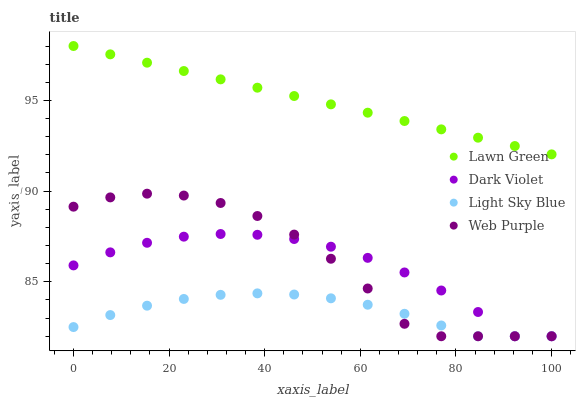Does Light Sky Blue have the minimum area under the curve?
Answer yes or no. Yes. Does Lawn Green have the maximum area under the curve?
Answer yes or no. Yes. Does Web Purple have the minimum area under the curve?
Answer yes or no. No. Does Web Purple have the maximum area under the curve?
Answer yes or no. No. Is Lawn Green the smoothest?
Answer yes or no. Yes. Is Web Purple the roughest?
Answer yes or no. Yes. Is Light Sky Blue the smoothest?
Answer yes or no. No. Is Light Sky Blue the roughest?
Answer yes or no. No. Does Web Purple have the lowest value?
Answer yes or no. Yes. Does Lawn Green have the highest value?
Answer yes or no. Yes. Does Web Purple have the highest value?
Answer yes or no. No. Is Light Sky Blue less than Lawn Green?
Answer yes or no. Yes. Is Lawn Green greater than Web Purple?
Answer yes or no. Yes. Does Light Sky Blue intersect Dark Violet?
Answer yes or no. Yes. Is Light Sky Blue less than Dark Violet?
Answer yes or no. No. Is Light Sky Blue greater than Dark Violet?
Answer yes or no. No. Does Light Sky Blue intersect Lawn Green?
Answer yes or no. No. 